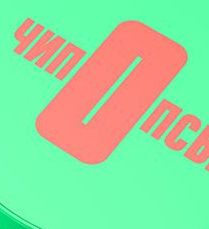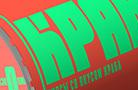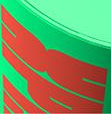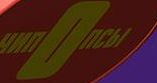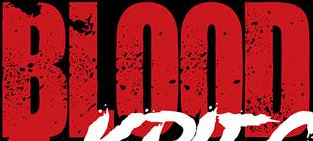Read the text content from these images in order, separated by a semicolon. nOnC; KPA; dk; nOnCbI; BLOOD 